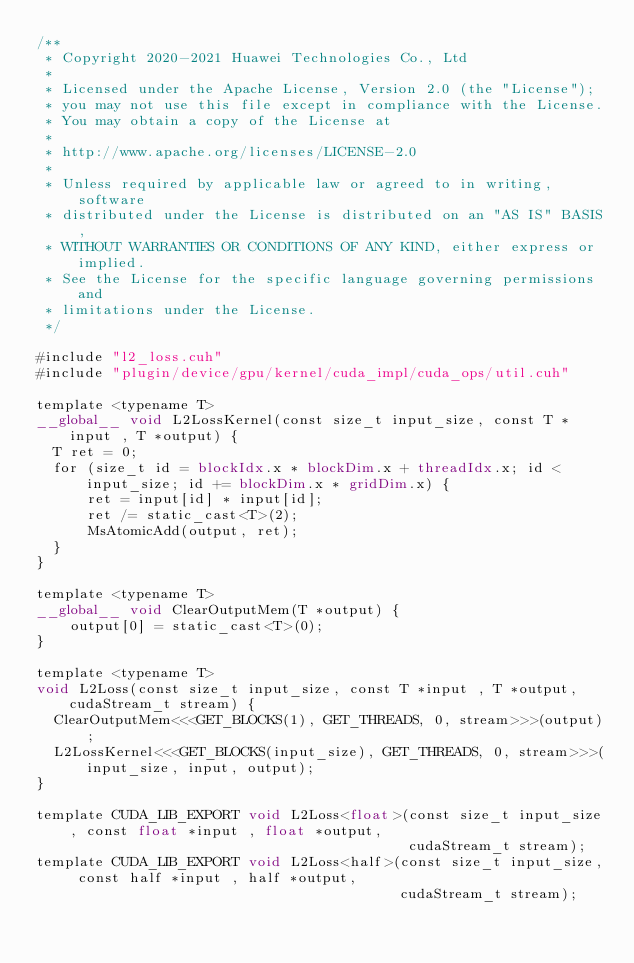<code> <loc_0><loc_0><loc_500><loc_500><_Cuda_>/**
 * Copyright 2020-2021 Huawei Technologies Co., Ltd
 *
 * Licensed under the Apache License, Version 2.0 (the "License");
 * you may not use this file except in compliance with the License.
 * You may obtain a copy of the License at
 *
 * http://www.apache.org/licenses/LICENSE-2.0
 *
 * Unless required by applicable law or agreed to in writing, software
 * distributed under the License is distributed on an "AS IS" BASIS,
 * WITHOUT WARRANTIES OR CONDITIONS OF ANY KIND, either express or implied.
 * See the License for the specific language governing permissions and
 * limitations under the License.
 */

#include "l2_loss.cuh"
#include "plugin/device/gpu/kernel/cuda_impl/cuda_ops/util.cuh"

template <typename T>
__global__ void L2LossKernel(const size_t input_size, const T *input , T *output) {
  T ret = 0;
  for (size_t id = blockIdx.x * blockDim.x + threadIdx.x; id < input_size; id += blockDim.x * gridDim.x) {
      ret = input[id] * input[id];
      ret /= static_cast<T>(2);
      MsAtomicAdd(output, ret);
  }
}

template <typename T>
__global__ void ClearOutputMem(T *output) {
    output[0] = static_cast<T>(0);
}

template <typename T>
void L2Loss(const size_t input_size, const T *input , T *output, cudaStream_t stream) {
  ClearOutputMem<<<GET_BLOCKS(1), GET_THREADS, 0, stream>>>(output);
  L2LossKernel<<<GET_BLOCKS(input_size), GET_THREADS, 0, stream>>>(input_size, input, output);
}

template CUDA_LIB_EXPORT void L2Loss<float>(const size_t input_size, const float *input , float *output,
                                            cudaStream_t stream);
template CUDA_LIB_EXPORT void L2Loss<half>(const size_t input_size, const half *input , half *output,
                                           cudaStream_t stream);
</code> 